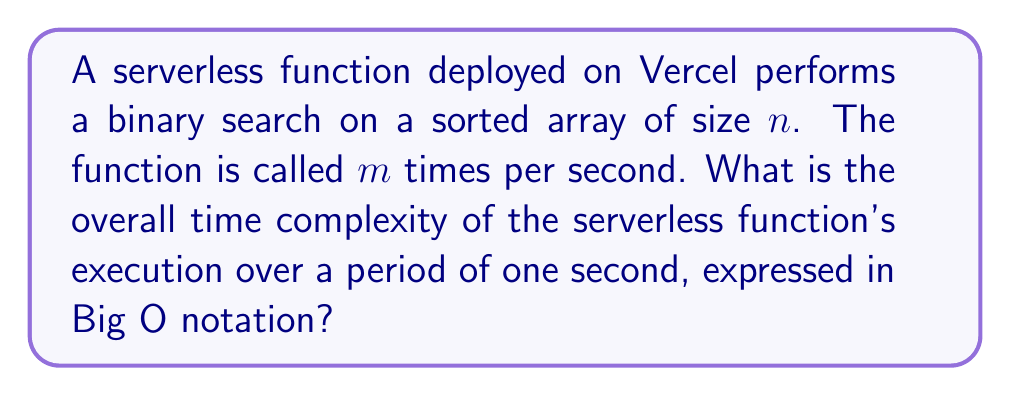Can you answer this question? To solve this problem, let's break it down into steps:

1. First, we need to understand the time complexity of a single binary search operation:
   - Binary search has a time complexity of $O(\log n)$, where $n$ is the size of the sorted array.

2. The serverless function is called $m$ times per second:
   - This means we're performing $m$ binary search operations.

3. To find the overall time complexity, we multiply the complexity of a single operation by the number of times it's performed:
   - Single operation: $O(\log n)$
   - Number of operations: $m$
   - Overall complexity: $O(m \log n)$

4. In Big O notation, we typically don't include constant factors. However, in this case, $m$ is not a constant related to the input size $n$, but rather a separate variable representing the number of function calls per second. Therefore, we keep both $m$ and $\log n$ in our final expression.

5. The time complexity remains $O(m \log n)$ over the period of one second, as specified in the question.

It's worth noting that in a serverless environment like Vercel, each function invocation is typically handled independently and may even run in parallel. However, from a computational complexity perspective, we consider the total work done across all invocations.
Answer: $O(m \log n)$ 